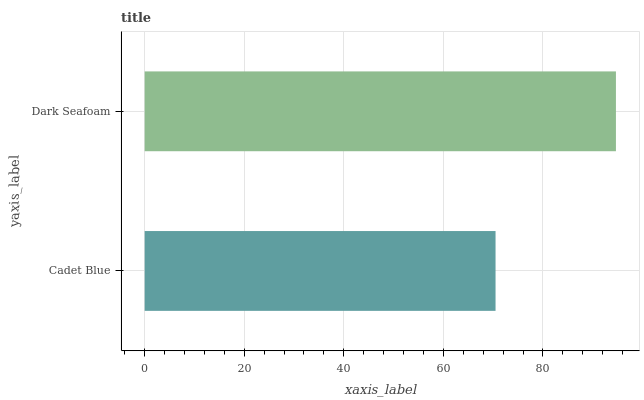Is Cadet Blue the minimum?
Answer yes or no. Yes. Is Dark Seafoam the maximum?
Answer yes or no. Yes. Is Dark Seafoam the minimum?
Answer yes or no. No. Is Dark Seafoam greater than Cadet Blue?
Answer yes or no. Yes. Is Cadet Blue less than Dark Seafoam?
Answer yes or no. Yes. Is Cadet Blue greater than Dark Seafoam?
Answer yes or no. No. Is Dark Seafoam less than Cadet Blue?
Answer yes or no. No. Is Dark Seafoam the high median?
Answer yes or no. Yes. Is Cadet Blue the low median?
Answer yes or no. Yes. Is Cadet Blue the high median?
Answer yes or no. No. Is Dark Seafoam the low median?
Answer yes or no. No. 